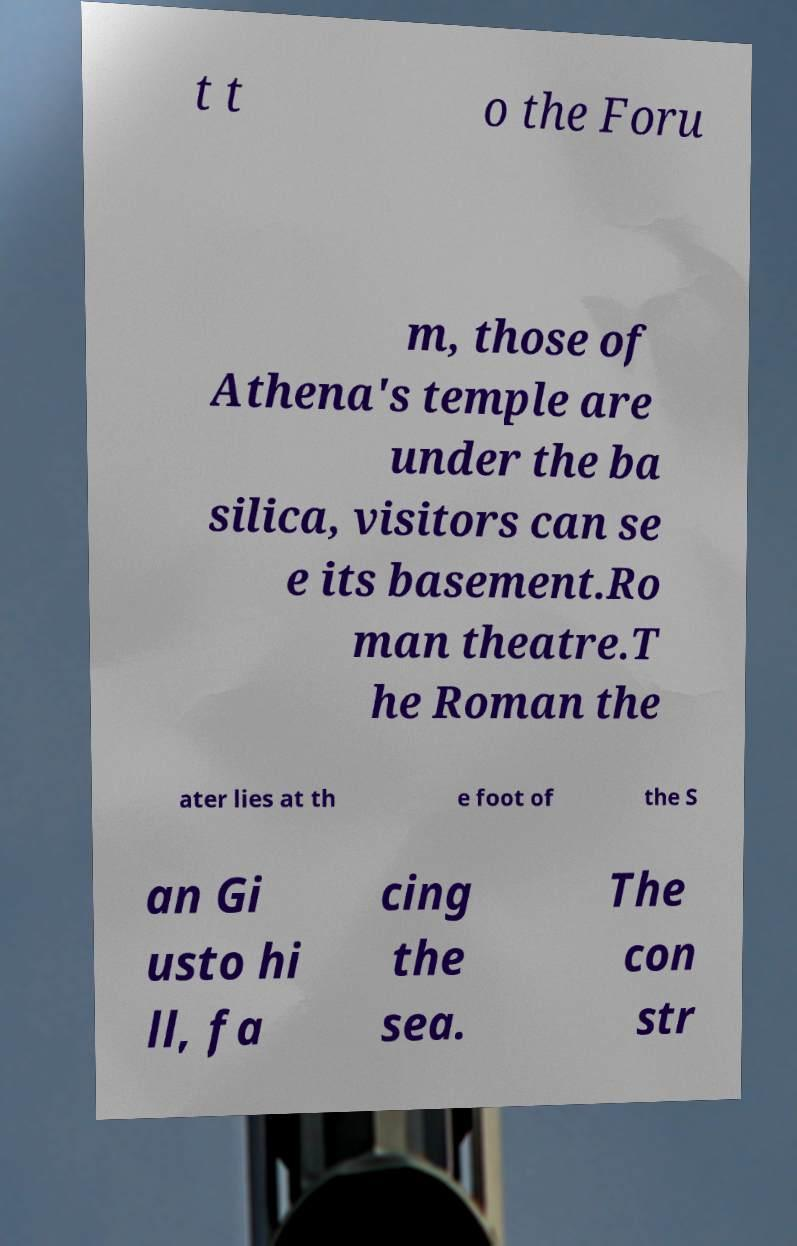What messages or text are displayed in this image? I need them in a readable, typed format. t t o the Foru m, those of Athena's temple are under the ba silica, visitors can se e its basement.Ro man theatre.T he Roman the ater lies at th e foot of the S an Gi usto hi ll, fa cing the sea. The con str 